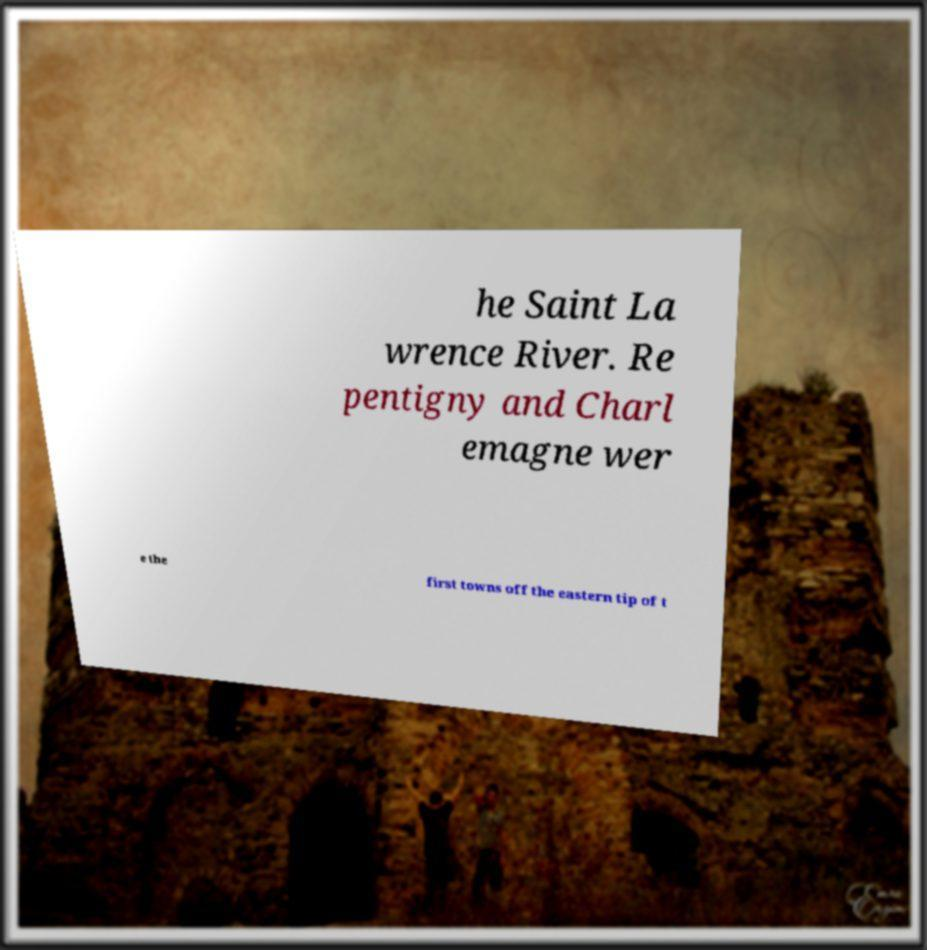Could you assist in decoding the text presented in this image and type it out clearly? he Saint La wrence River. Re pentigny and Charl emagne wer e the first towns off the eastern tip of t 